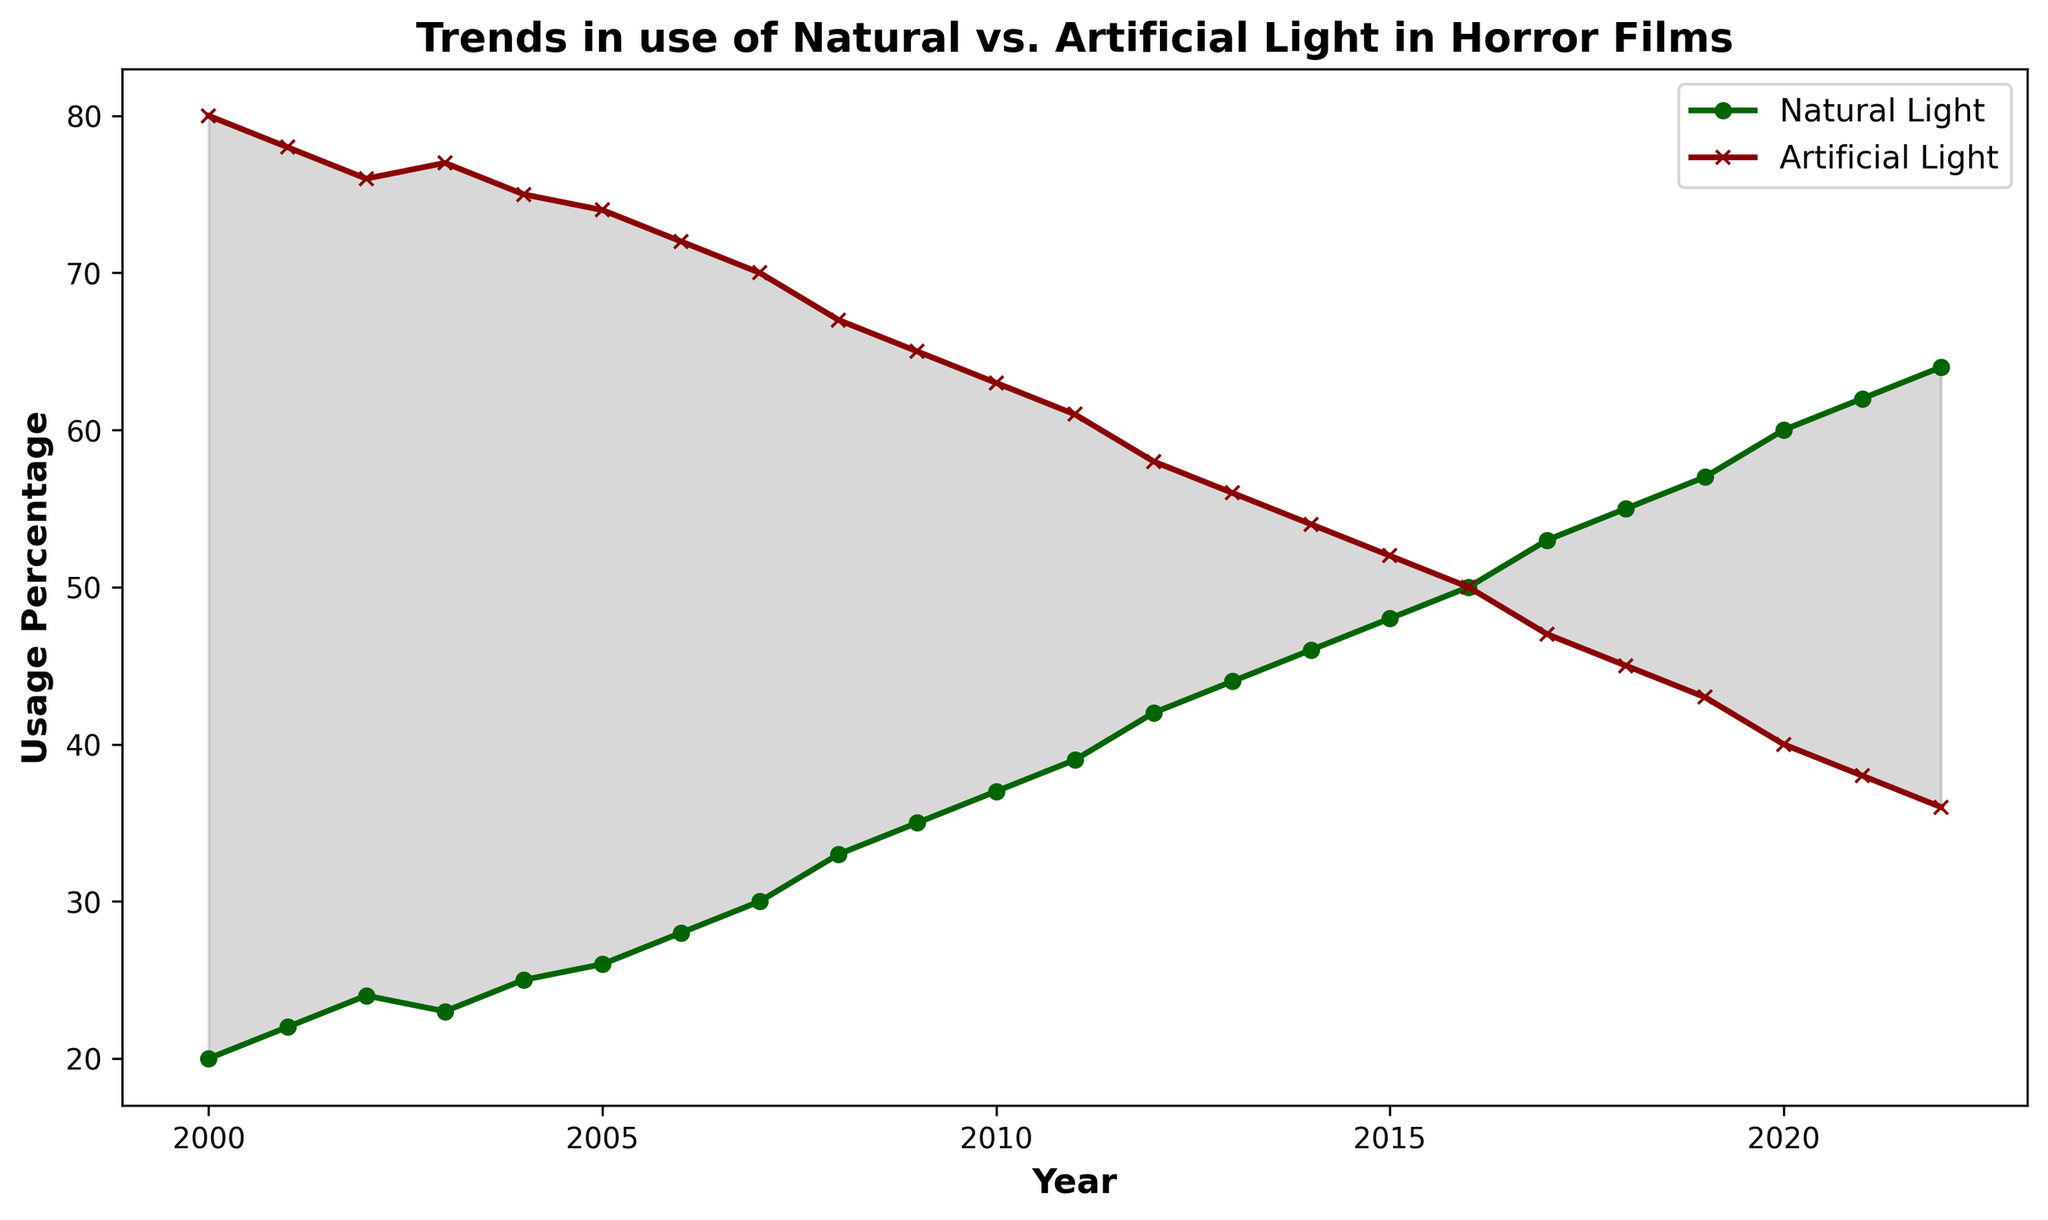How did the use of natural light change from 2000 to 2022? To determine the change in the use of natural light from 2000 to 2022, locate the percentage values for natural light in both years. In 2000, it’s 20%, and in 2022, it’s 64%. The change is 64% - 20% = 44%.
Answer: 44% Which light type had a more consistent usage trend over the years, natural or artificial light? To find out which light type had a more consistent usage trend, look at the slopes of the lines representing natural and artificial light. The natural light trend is consistently increasing, whereas the artificial light trend is consistently decreasing. Both trends show consistency, but in opposite directions.
Answer: Both had consistent trends Did natural light usage ever surpass artificial light usage over the years? By examining the plot lines, determine if the natural light percentage ever exceeded the artificial light percentage. This happens when the natural light line is above the artificial light line. From around 2016 onward, natural light usage surpasses artificial light usage.
Answer: Yes At which point did the usage rates of natural and artificial light equal each other? Find the year where the two lines intersect, indicating equal usage rates. This occurs in 2016 where both natural and artificial light are at 50%.
Answer: 2016 Which year saw the highest percentage of natural light usage? To identify the peak of natural light usage, look for the highest point on the natural light trend line. In 2022, it reaches its highest at 64%.
Answer: 2022 What is the overall trend for artificial light usage from 2000 to 2022? To describe the trend, observe the artificial light line from start to end. It shows a consistent decline from 80% in 2000 to 36% in 2022.
Answer: Decreasing Calculate the average usage percentage of natural light over the entire period. Sum the annual percentages of natural light from 2000 to 2022 and divide by the number of years. (20+22+24+23+25+26+28+30+33+35+37+39+42+44+46+48+50+53+55+57+60+62+64)/23 = 39.17 (approximately).
Answer: 39.17% How does the visual representation (with filled areas) help interpret the changes between natural and artificial light usage? The filled area between the lines visually emphasizes the gap between natural and artificial light usage. A wide gap indicates a significant difference, and a narrow gap indicates convergence. This helps in quickly grasping the relative usage changes over time.
Answer: Emphasizes usage gap From 2010 onwards, how many years did the usage of natural light increase consecutively? Evaluate the natural light trend line from 2010 to 2022. From 2010 (37%) to 2022 (64%), the trend shows continuous increase every year, which means 12 years of consecutive increase.
Answer: 12 years 